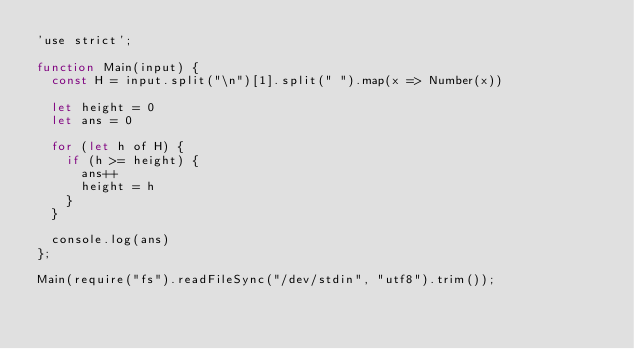<code> <loc_0><loc_0><loc_500><loc_500><_JavaScript_>'use strict';

function Main(input) {
  const H = input.split("\n")[1].split(" ").map(x => Number(x))
  
  let height = 0
  let ans = 0

  for (let h of H) {
    if (h >= height) {
      ans++
      height = h
    }
  }

  console.log(ans)  
};

Main(require("fs").readFileSync("/dev/stdin", "utf8").trim());
</code> 